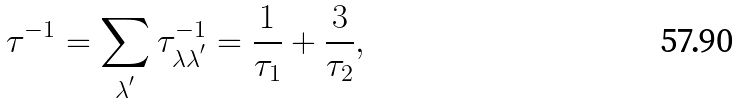Convert formula to latex. <formula><loc_0><loc_0><loc_500><loc_500>\tau ^ { - 1 } = \sum _ { \lambda ^ { ^ { \prime } } } \tau _ { \lambda \lambda ^ { ^ { \prime } } } ^ { - 1 } = \frac { 1 } { \tau _ { 1 } } + \frac { 3 } { \tau _ { 2 } } ,</formula> 